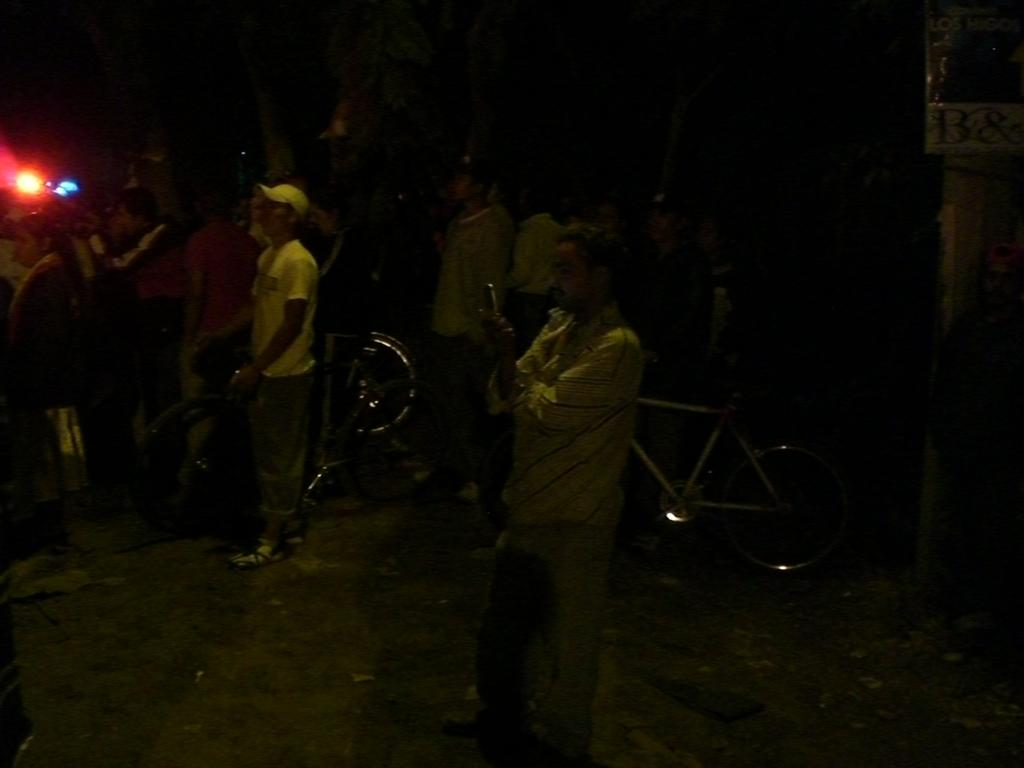What are the people in the image doing? The people in the image are standing on the ground. What objects can be seen near the people? There are bicycles in the image. What can be used to provide illumination in the image? There is a light in the image. What message or information is displayed in the image? There is a board with text in the image. How would you describe the overall lighting condition in the image? The background of the image is dark. How does the drain affect the bicycles in the image? There is no drain present in the image, so it cannot affect the bicycles. 